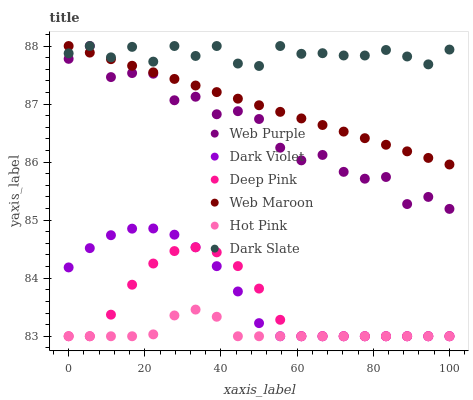Does Hot Pink have the minimum area under the curve?
Answer yes or no. Yes. Does Dark Slate have the maximum area under the curve?
Answer yes or no. Yes. Does Web Maroon have the minimum area under the curve?
Answer yes or no. No. Does Web Maroon have the maximum area under the curve?
Answer yes or no. No. Is Web Maroon the smoothest?
Answer yes or no. Yes. Is Web Purple the roughest?
Answer yes or no. Yes. Is Hot Pink the smoothest?
Answer yes or no. No. Is Hot Pink the roughest?
Answer yes or no. No. Does Deep Pink have the lowest value?
Answer yes or no. Yes. Does Web Maroon have the lowest value?
Answer yes or no. No. Does Web Purple have the highest value?
Answer yes or no. Yes. Does Hot Pink have the highest value?
Answer yes or no. No. Is Hot Pink less than Web Maroon?
Answer yes or no. Yes. Is Web Purple greater than Hot Pink?
Answer yes or no. Yes. Does Web Maroon intersect Dark Slate?
Answer yes or no. Yes. Is Web Maroon less than Dark Slate?
Answer yes or no. No. Is Web Maroon greater than Dark Slate?
Answer yes or no. No. Does Hot Pink intersect Web Maroon?
Answer yes or no. No. 